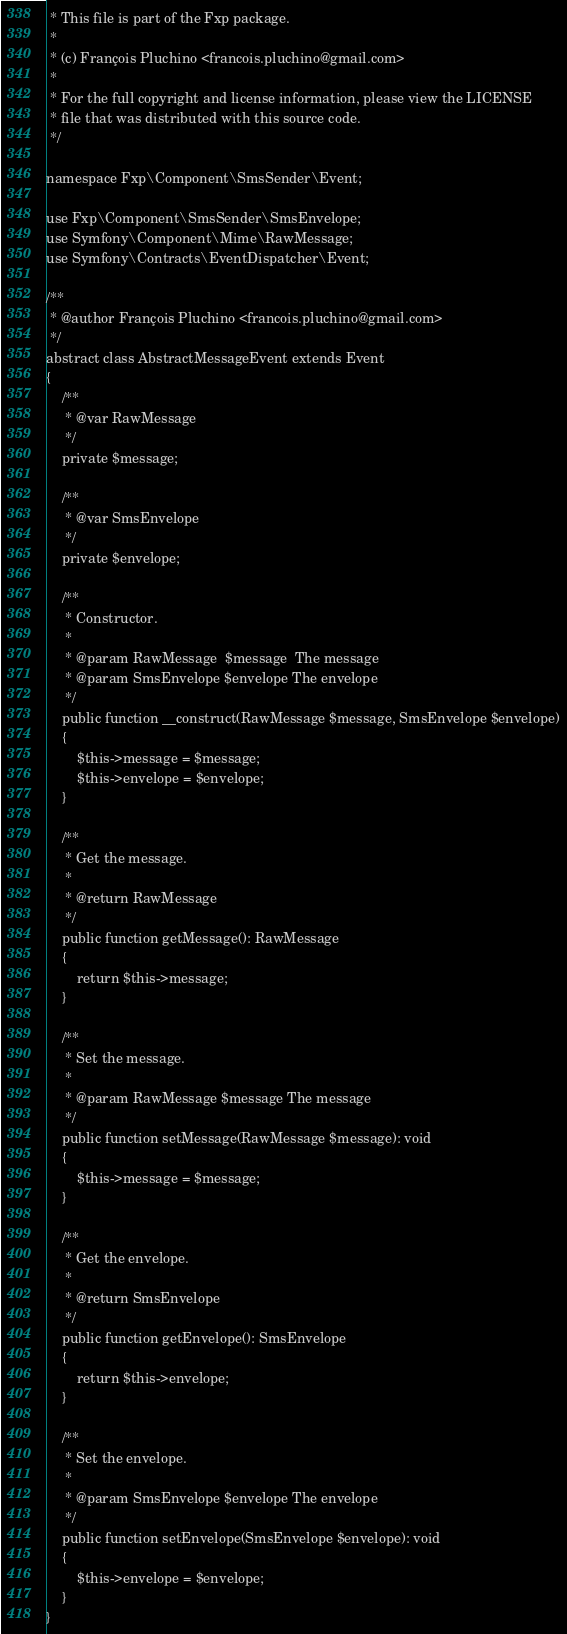Convert code to text. <code><loc_0><loc_0><loc_500><loc_500><_PHP_> * This file is part of the Fxp package.
 *
 * (c) François Pluchino <francois.pluchino@gmail.com>
 *
 * For the full copyright and license information, please view the LICENSE
 * file that was distributed with this source code.
 */

namespace Fxp\Component\SmsSender\Event;

use Fxp\Component\SmsSender\SmsEnvelope;
use Symfony\Component\Mime\RawMessage;
use Symfony\Contracts\EventDispatcher\Event;

/**
 * @author François Pluchino <francois.pluchino@gmail.com>
 */
abstract class AbstractMessageEvent extends Event
{
    /**
     * @var RawMessage
     */
    private $message;

    /**
     * @var SmsEnvelope
     */
    private $envelope;

    /**
     * Constructor.
     *
     * @param RawMessage  $message  The message
     * @param SmsEnvelope $envelope The envelope
     */
    public function __construct(RawMessage $message, SmsEnvelope $envelope)
    {
        $this->message = $message;
        $this->envelope = $envelope;
    }

    /**
     * Get the message.
     *
     * @return RawMessage
     */
    public function getMessage(): RawMessage
    {
        return $this->message;
    }

    /**
     * Set the message.
     *
     * @param RawMessage $message The message
     */
    public function setMessage(RawMessage $message): void
    {
        $this->message = $message;
    }

    /**
     * Get the envelope.
     *
     * @return SmsEnvelope
     */
    public function getEnvelope(): SmsEnvelope
    {
        return $this->envelope;
    }

    /**
     * Set the envelope.
     *
     * @param SmsEnvelope $envelope The envelope
     */
    public function setEnvelope(SmsEnvelope $envelope): void
    {
        $this->envelope = $envelope;
    }
}
</code> 